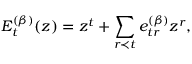Convert formula to latex. <formula><loc_0><loc_0><loc_500><loc_500>E _ { t } ^ { ( \beta ) } ( z ) = z ^ { t } + \sum _ { r \prec t } e _ { t r } ^ { ( \beta ) } z ^ { r } ,</formula> 